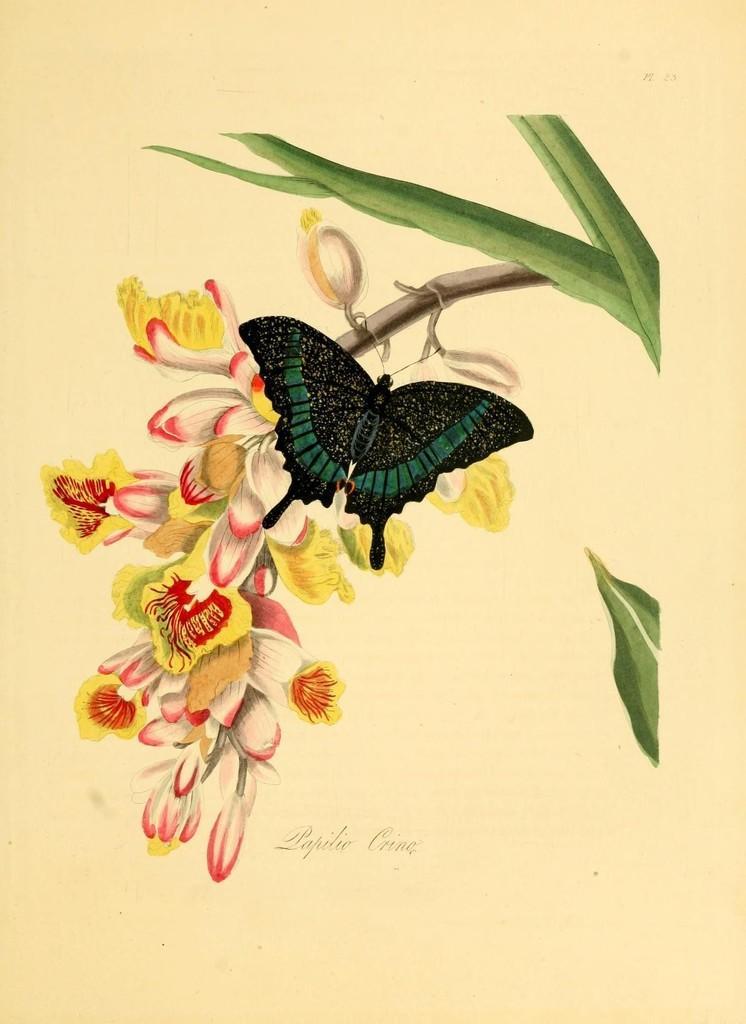How would you summarize this image in a sentence or two? As we can see in the image there is a paper. On paper there is a drawing of a tree branch, butterfly and flowers. 